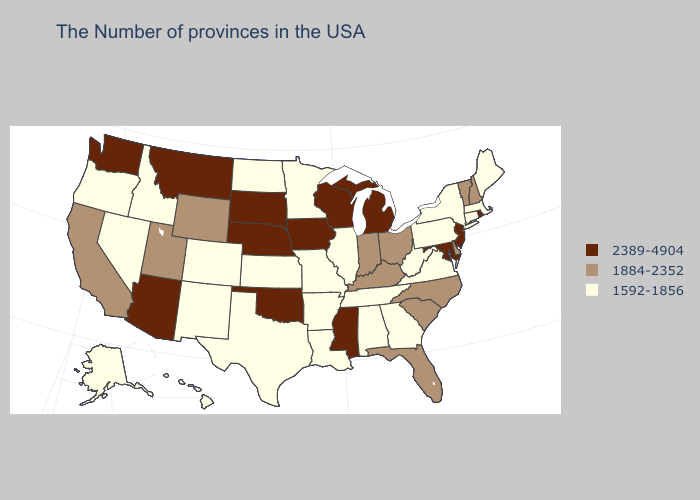Which states have the lowest value in the USA?
Write a very short answer. Maine, Massachusetts, Connecticut, New York, Pennsylvania, Virginia, West Virginia, Georgia, Alabama, Tennessee, Illinois, Louisiana, Missouri, Arkansas, Minnesota, Kansas, Texas, North Dakota, Colorado, New Mexico, Idaho, Nevada, Oregon, Alaska, Hawaii. Does the map have missing data?
Concise answer only. No. Does the first symbol in the legend represent the smallest category?
Answer briefly. No. Does Alaska have a lower value than Nevada?
Keep it brief. No. Name the states that have a value in the range 1884-2352?
Answer briefly. New Hampshire, Vermont, Delaware, North Carolina, South Carolina, Ohio, Florida, Kentucky, Indiana, Wyoming, Utah, California. How many symbols are there in the legend?
Concise answer only. 3. What is the value of Kansas?
Be succinct. 1592-1856. What is the value of Arkansas?
Be succinct. 1592-1856. Does the map have missing data?
Short answer required. No. Does Oregon have the highest value in the USA?
Give a very brief answer. No. Does Ohio have a higher value than Oklahoma?
Short answer required. No. What is the lowest value in the West?
Keep it brief. 1592-1856. Among the states that border Colorado , does Kansas have the lowest value?
Keep it brief. Yes. Does the map have missing data?
Give a very brief answer. No. Name the states that have a value in the range 2389-4904?
Keep it brief. Rhode Island, New Jersey, Maryland, Michigan, Wisconsin, Mississippi, Iowa, Nebraska, Oklahoma, South Dakota, Montana, Arizona, Washington. 